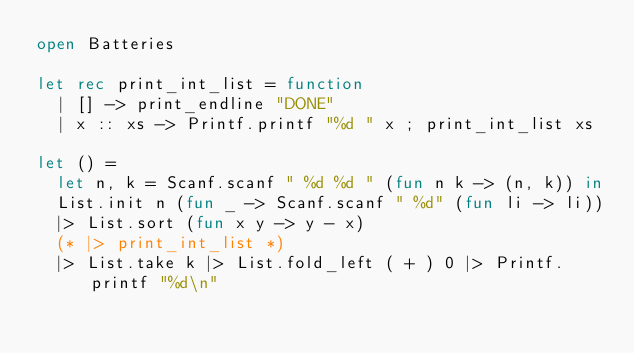<code> <loc_0><loc_0><loc_500><loc_500><_OCaml_>open Batteries

let rec print_int_list = function
  | [] -> print_endline "DONE"
  | x :: xs -> Printf.printf "%d " x ; print_int_list xs

let () =
  let n, k = Scanf.scanf " %d %d " (fun n k -> (n, k)) in
  List.init n (fun _ -> Scanf.scanf " %d" (fun li -> li))
  |> List.sort (fun x y -> y - x)
  (* |> print_int_list *)
  |> List.take k |> List.fold_left ( + ) 0 |> Printf.printf "%d\n"
</code> 